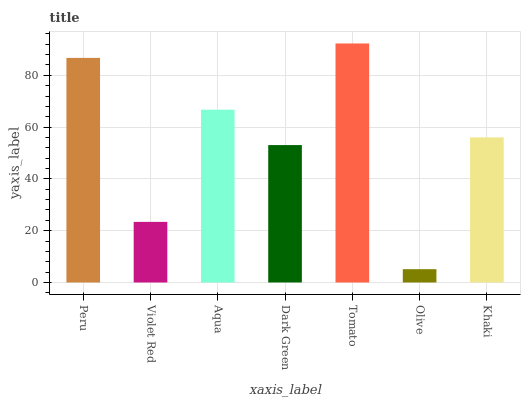Is Olive the minimum?
Answer yes or no. Yes. Is Tomato the maximum?
Answer yes or no. Yes. Is Violet Red the minimum?
Answer yes or no. No. Is Violet Red the maximum?
Answer yes or no. No. Is Peru greater than Violet Red?
Answer yes or no. Yes. Is Violet Red less than Peru?
Answer yes or no. Yes. Is Violet Red greater than Peru?
Answer yes or no. No. Is Peru less than Violet Red?
Answer yes or no. No. Is Khaki the high median?
Answer yes or no. Yes. Is Khaki the low median?
Answer yes or no. Yes. Is Dark Green the high median?
Answer yes or no. No. Is Tomato the low median?
Answer yes or no. No. 